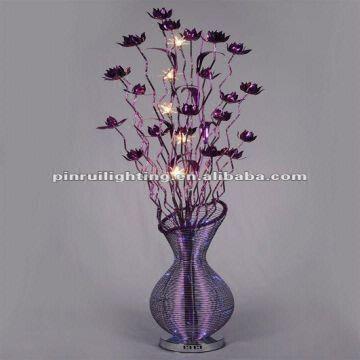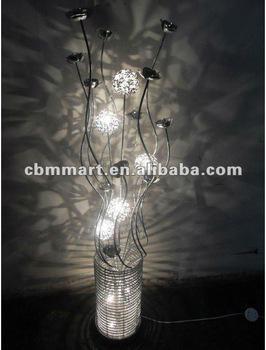The first image is the image on the left, the second image is the image on the right. For the images displayed, is the sentence "There is a silver lamp with white lights in the right image." factually correct? Answer yes or no. Yes. The first image is the image on the left, the second image is the image on the right. Evaluate the accuracy of this statement regarding the images: "white and black flowered shaped lights in a glass vase". Is it true? Answer yes or no. Yes. 